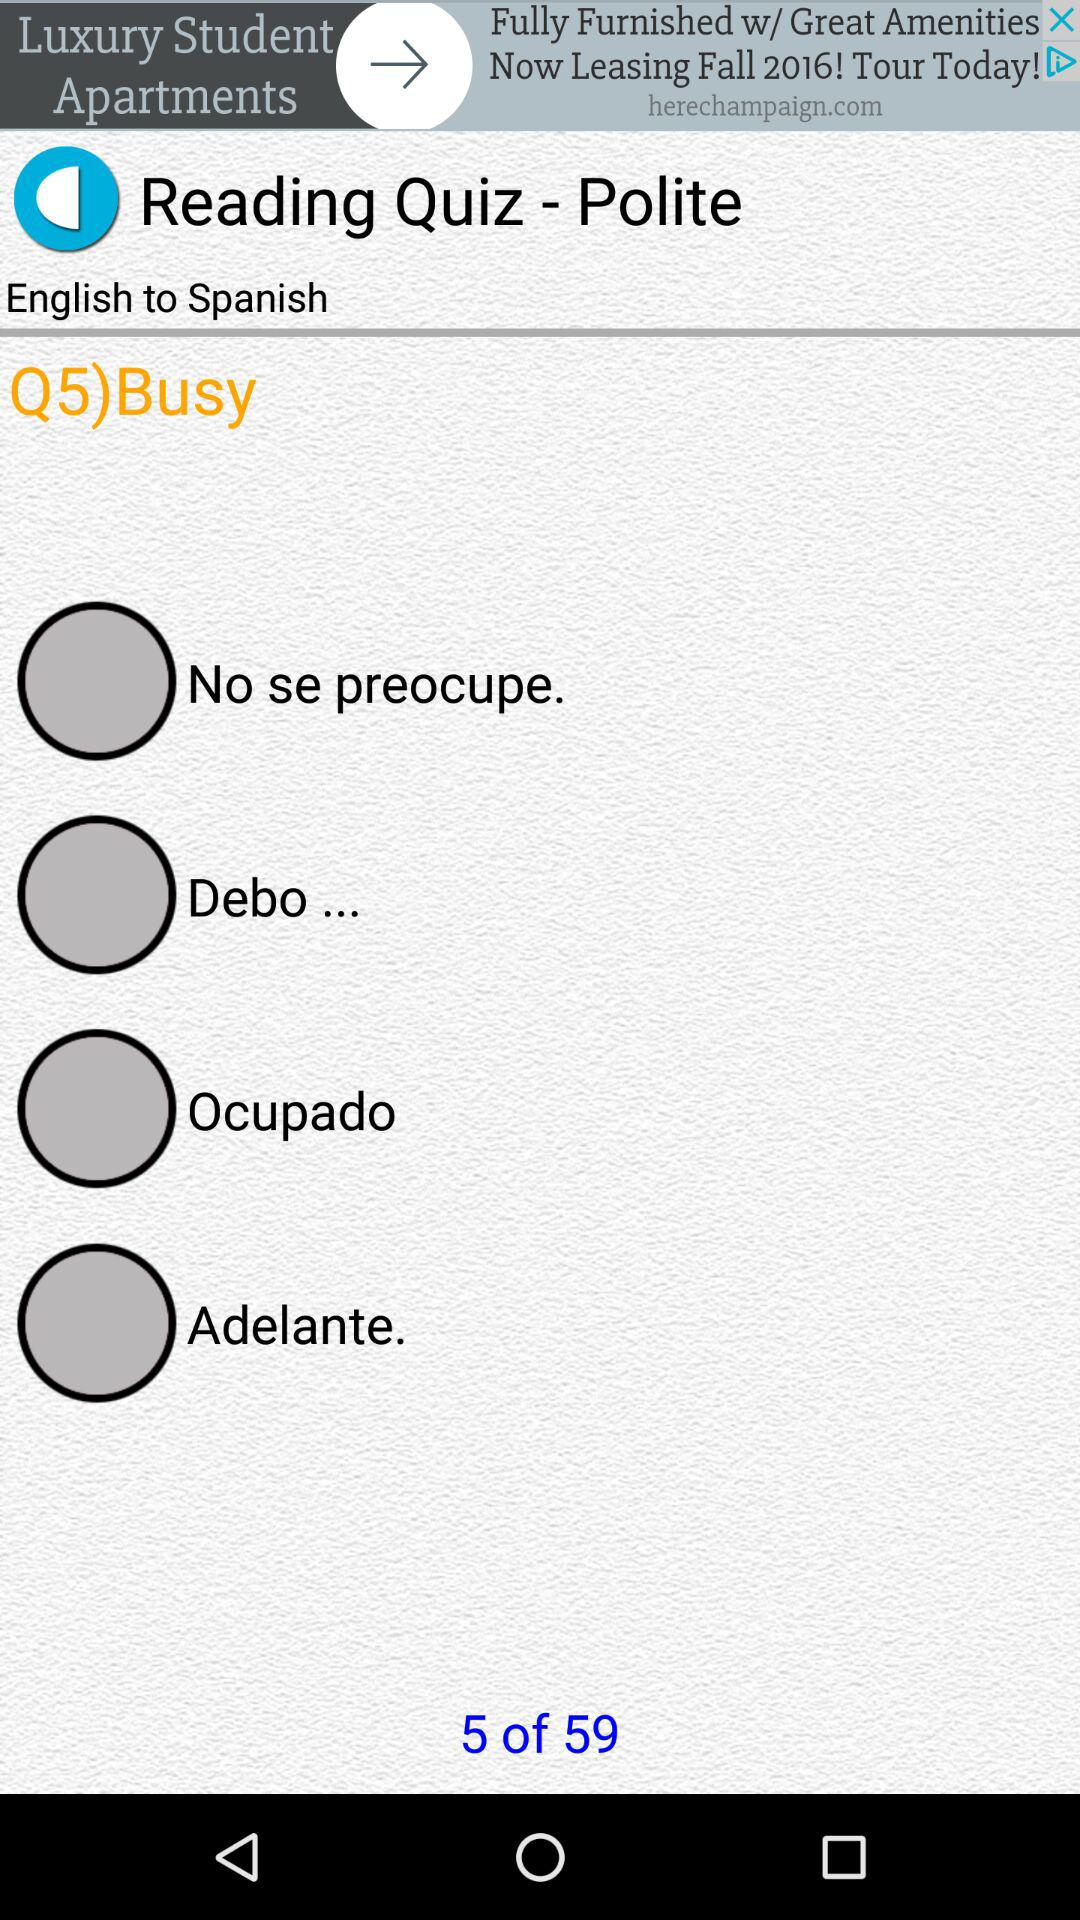How many quiz questions are there? There are 59 quiz questions. 